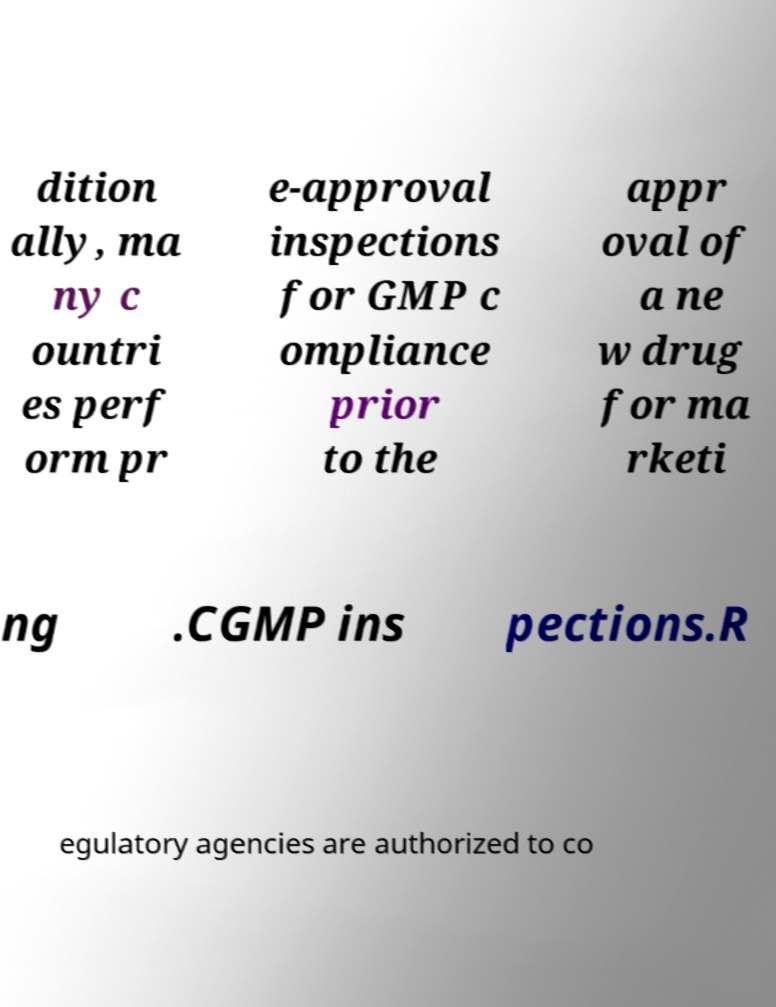Could you extract and type out the text from this image? dition ally, ma ny c ountri es perf orm pr e-approval inspections for GMP c ompliance prior to the appr oval of a ne w drug for ma rketi ng .CGMP ins pections.R egulatory agencies are authorized to co 